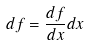Convert formula to latex. <formula><loc_0><loc_0><loc_500><loc_500>d f = \frac { d f } { d x } d x</formula> 